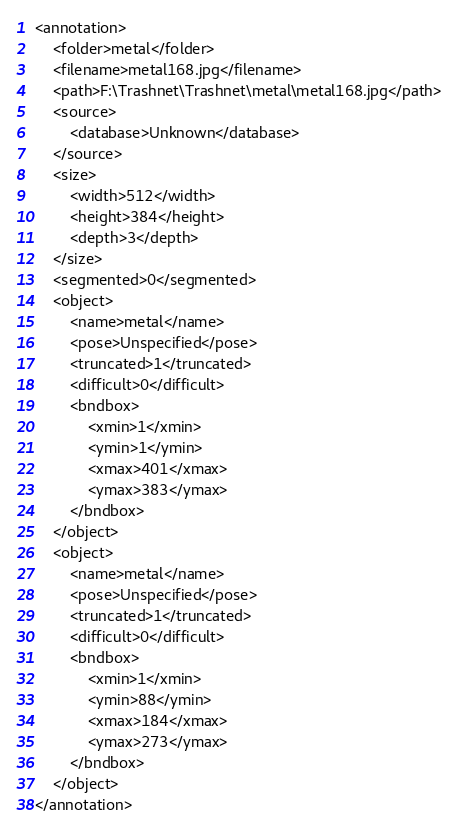Convert code to text. <code><loc_0><loc_0><loc_500><loc_500><_XML_><annotation>
	<folder>metal</folder>
	<filename>metal168.jpg</filename>
	<path>F:\Trashnet\Trashnet\metal\metal168.jpg</path>
	<source>
		<database>Unknown</database>
	</source>
	<size>
		<width>512</width>
		<height>384</height>
		<depth>3</depth>
	</size>
	<segmented>0</segmented>
	<object>
		<name>metal</name>
		<pose>Unspecified</pose>
		<truncated>1</truncated>
		<difficult>0</difficult>
		<bndbox>
			<xmin>1</xmin>
			<ymin>1</ymin>
			<xmax>401</xmax>
			<ymax>383</ymax>
		</bndbox>
	</object>
	<object>
		<name>metal</name>
		<pose>Unspecified</pose>
		<truncated>1</truncated>
		<difficult>0</difficult>
		<bndbox>
			<xmin>1</xmin>
			<ymin>88</ymin>
			<xmax>184</xmax>
			<ymax>273</ymax>
		</bndbox>
	</object>
</annotation>
</code> 